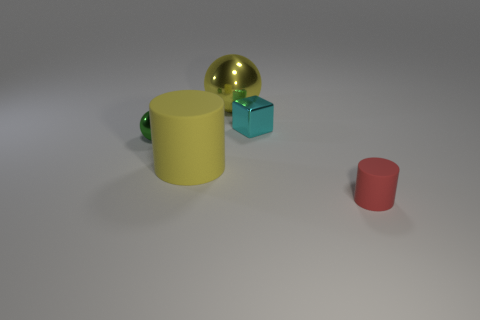Add 2 red shiny cylinders. How many objects exist? 7 Subtract all cylinders. How many objects are left? 3 Subtract 0 cyan cylinders. How many objects are left? 5 Subtract all tiny red cylinders. Subtract all spheres. How many objects are left? 2 Add 2 green shiny things. How many green shiny things are left? 3 Add 5 big brown shiny cubes. How many big brown shiny cubes exist? 5 